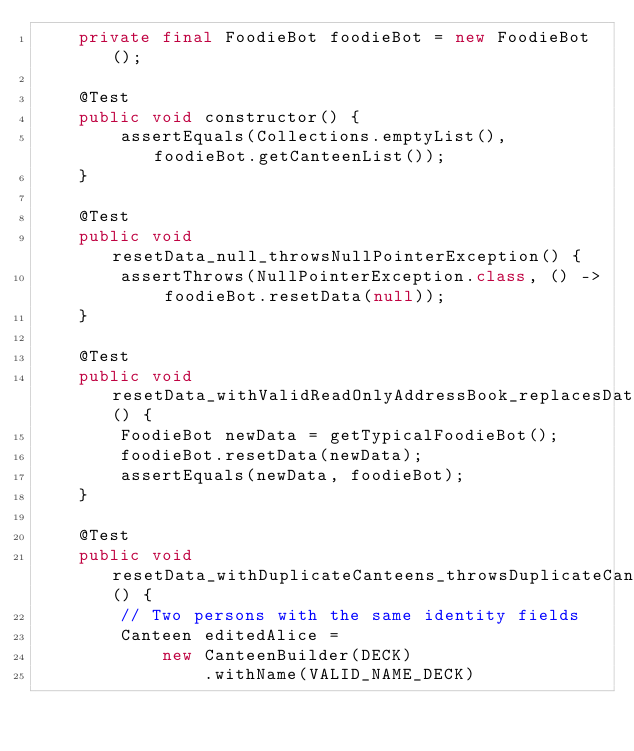<code> <loc_0><loc_0><loc_500><loc_500><_Java_>    private final FoodieBot foodieBot = new FoodieBot();

    @Test
    public void constructor() {
        assertEquals(Collections.emptyList(), foodieBot.getCanteenList());
    }

    @Test
    public void resetData_null_throwsNullPointerException() {
        assertThrows(NullPointerException.class, () -> foodieBot.resetData(null));
    }

    @Test
    public void resetData_withValidReadOnlyAddressBook_replacesData() {
        FoodieBot newData = getTypicalFoodieBot();
        foodieBot.resetData(newData);
        assertEquals(newData, foodieBot);
    }

    @Test
    public void resetData_withDuplicateCanteens_throwsDuplicateCanteenException() {
        // Two persons with the same identity fields
        Canteen editedAlice =
            new CanteenBuilder(DECK)
                .withName(VALID_NAME_DECK)</code> 